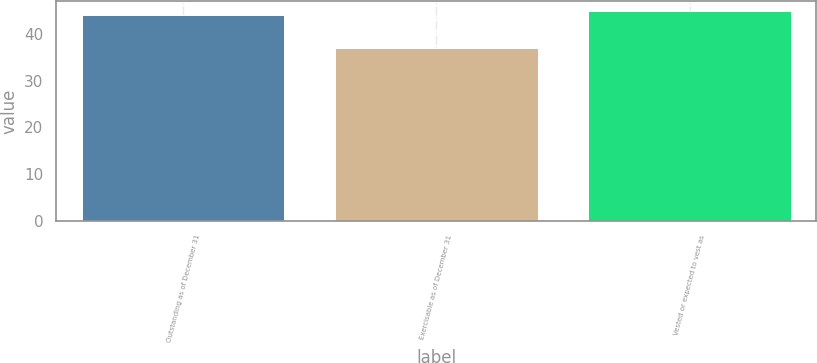Convert chart to OTSL. <chart><loc_0><loc_0><loc_500><loc_500><bar_chart><fcel>Outstanding as of December 31<fcel>Exercisable as of December 31<fcel>Vested or expected to vest as<nl><fcel>44.09<fcel>37.07<fcel>44.79<nl></chart> 